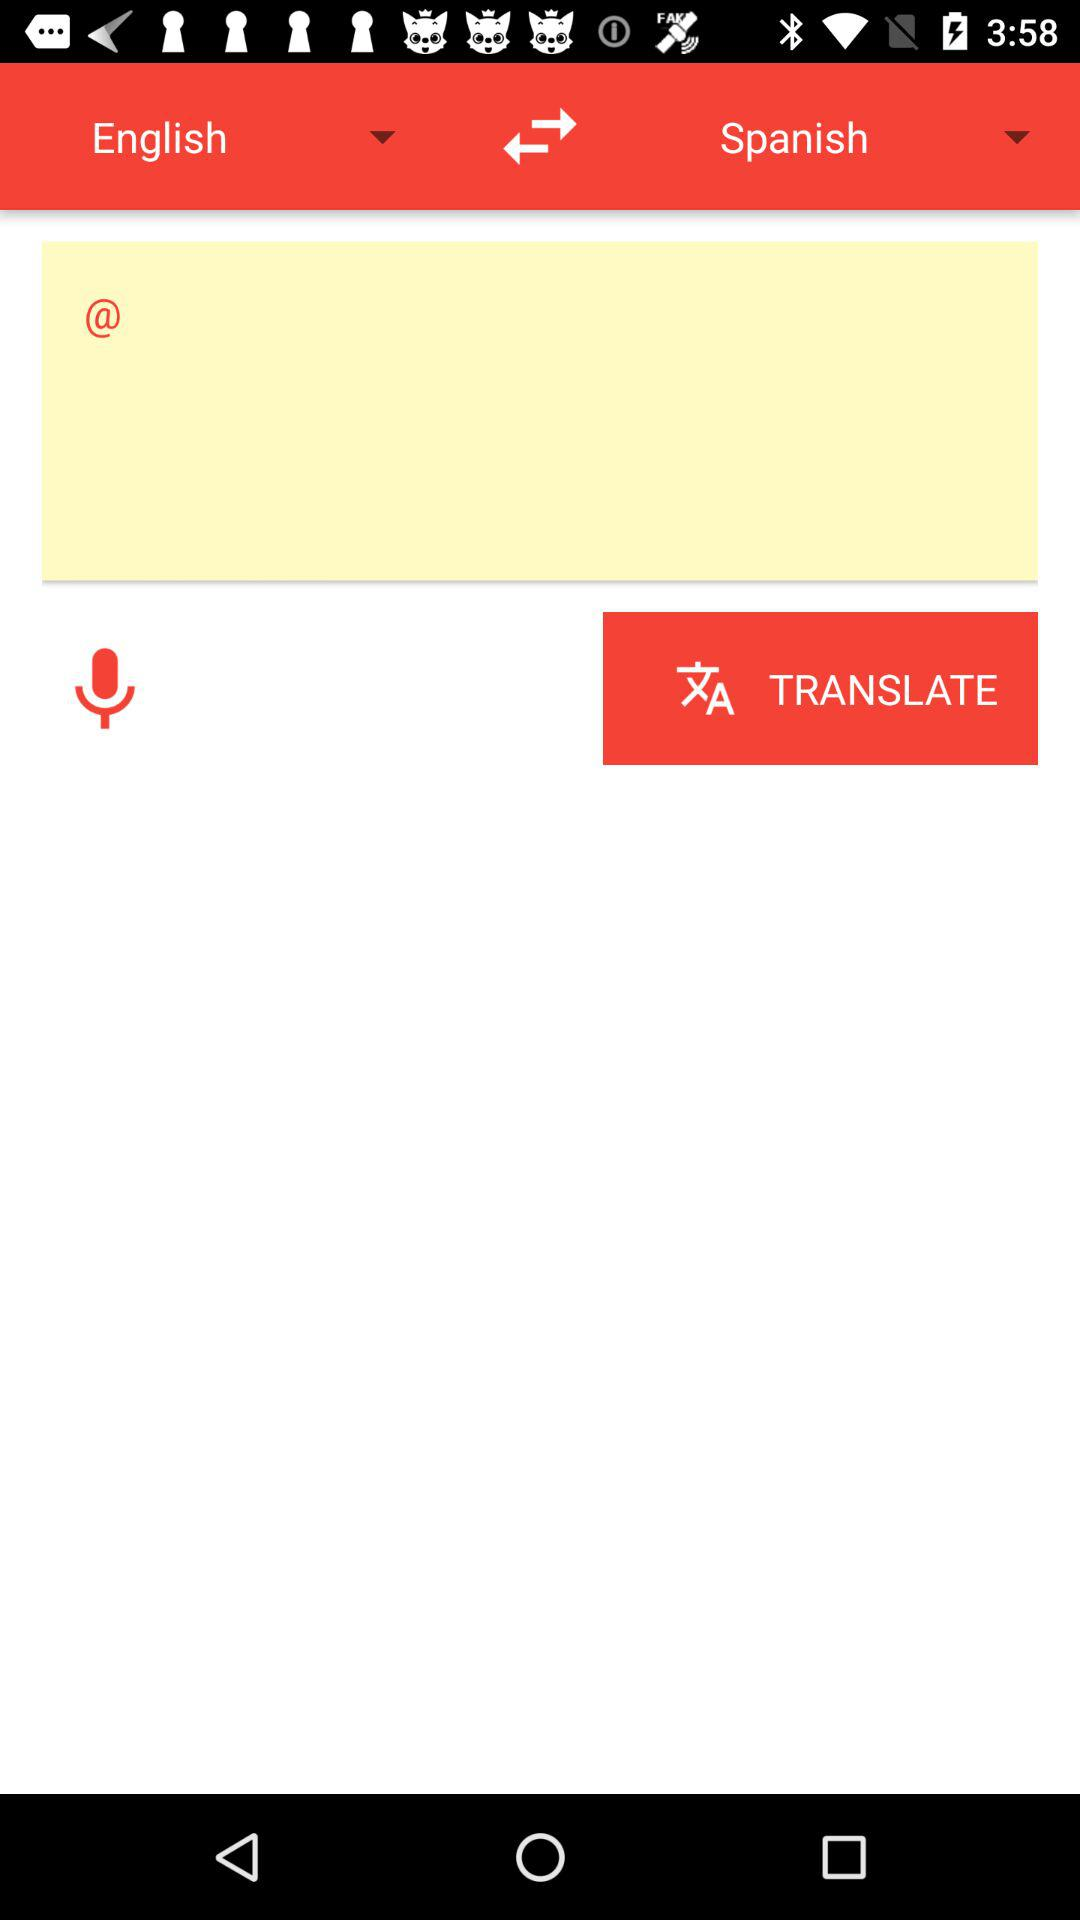In which language is the English language translated? The English language is translated into the Spanish language. 